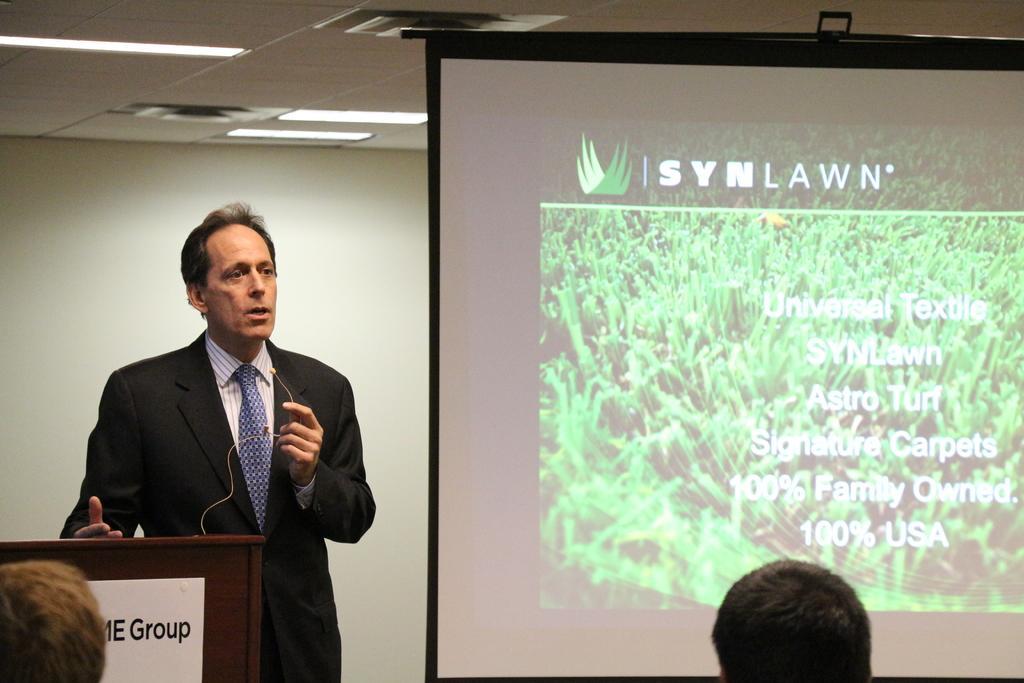In one or two sentences, can you explain what this image depicts? On the left side of the image there is a person standing at the desk. On the right side there is a screen. At the bottom we can see persons. At the top there is a tube light and ceiling. In the background there is a wall. 